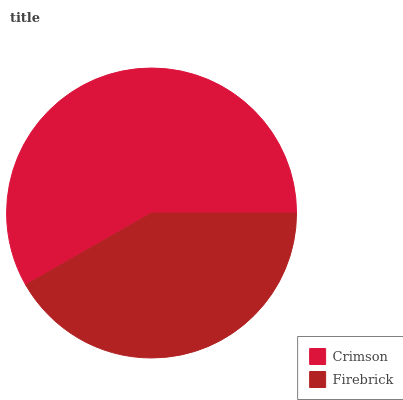Is Firebrick the minimum?
Answer yes or no. Yes. Is Crimson the maximum?
Answer yes or no. Yes. Is Firebrick the maximum?
Answer yes or no. No. Is Crimson greater than Firebrick?
Answer yes or no. Yes. Is Firebrick less than Crimson?
Answer yes or no. Yes. Is Firebrick greater than Crimson?
Answer yes or no. No. Is Crimson less than Firebrick?
Answer yes or no. No. Is Crimson the high median?
Answer yes or no. Yes. Is Firebrick the low median?
Answer yes or no. Yes. Is Firebrick the high median?
Answer yes or no. No. Is Crimson the low median?
Answer yes or no. No. 